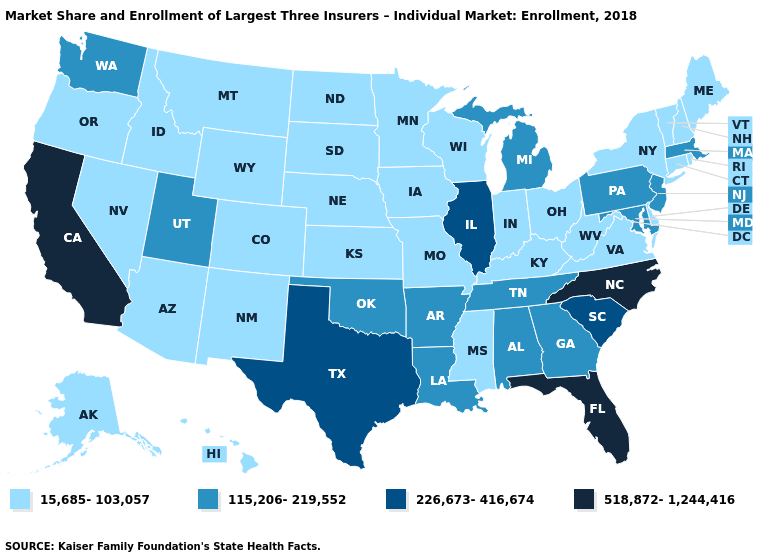Name the states that have a value in the range 226,673-416,674?
Concise answer only. Illinois, South Carolina, Texas. Does Oklahoma have the lowest value in the USA?
Concise answer only. No. What is the value of Alabama?
Be succinct. 115,206-219,552. What is the lowest value in the MidWest?
Short answer required. 15,685-103,057. Does the map have missing data?
Keep it brief. No. Does the map have missing data?
Concise answer only. No. Name the states that have a value in the range 518,872-1,244,416?
Answer briefly. California, Florida, North Carolina. Name the states that have a value in the range 226,673-416,674?
Give a very brief answer. Illinois, South Carolina, Texas. Which states hav the highest value in the MidWest?
Write a very short answer. Illinois. Which states have the lowest value in the USA?
Give a very brief answer. Alaska, Arizona, Colorado, Connecticut, Delaware, Hawaii, Idaho, Indiana, Iowa, Kansas, Kentucky, Maine, Minnesota, Mississippi, Missouri, Montana, Nebraska, Nevada, New Hampshire, New Mexico, New York, North Dakota, Ohio, Oregon, Rhode Island, South Dakota, Vermont, Virginia, West Virginia, Wisconsin, Wyoming. What is the value of Arkansas?
Keep it brief. 115,206-219,552. What is the lowest value in states that border New York?
Quick response, please. 15,685-103,057. Name the states that have a value in the range 15,685-103,057?
Give a very brief answer. Alaska, Arizona, Colorado, Connecticut, Delaware, Hawaii, Idaho, Indiana, Iowa, Kansas, Kentucky, Maine, Minnesota, Mississippi, Missouri, Montana, Nebraska, Nevada, New Hampshire, New Mexico, New York, North Dakota, Ohio, Oregon, Rhode Island, South Dakota, Vermont, Virginia, West Virginia, Wisconsin, Wyoming. What is the value of New York?
Answer briefly. 15,685-103,057. 